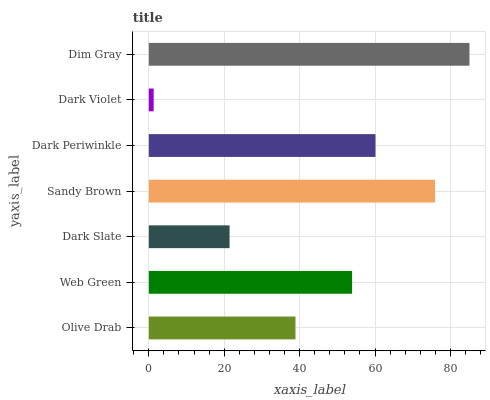Is Dark Violet the minimum?
Answer yes or no. Yes. Is Dim Gray the maximum?
Answer yes or no. Yes. Is Web Green the minimum?
Answer yes or no. No. Is Web Green the maximum?
Answer yes or no. No. Is Web Green greater than Olive Drab?
Answer yes or no. Yes. Is Olive Drab less than Web Green?
Answer yes or no. Yes. Is Olive Drab greater than Web Green?
Answer yes or no. No. Is Web Green less than Olive Drab?
Answer yes or no. No. Is Web Green the high median?
Answer yes or no. Yes. Is Web Green the low median?
Answer yes or no. Yes. Is Dark Periwinkle the high median?
Answer yes or no. No. Is Olive Drab the low median?
Answer yes or no. No. 